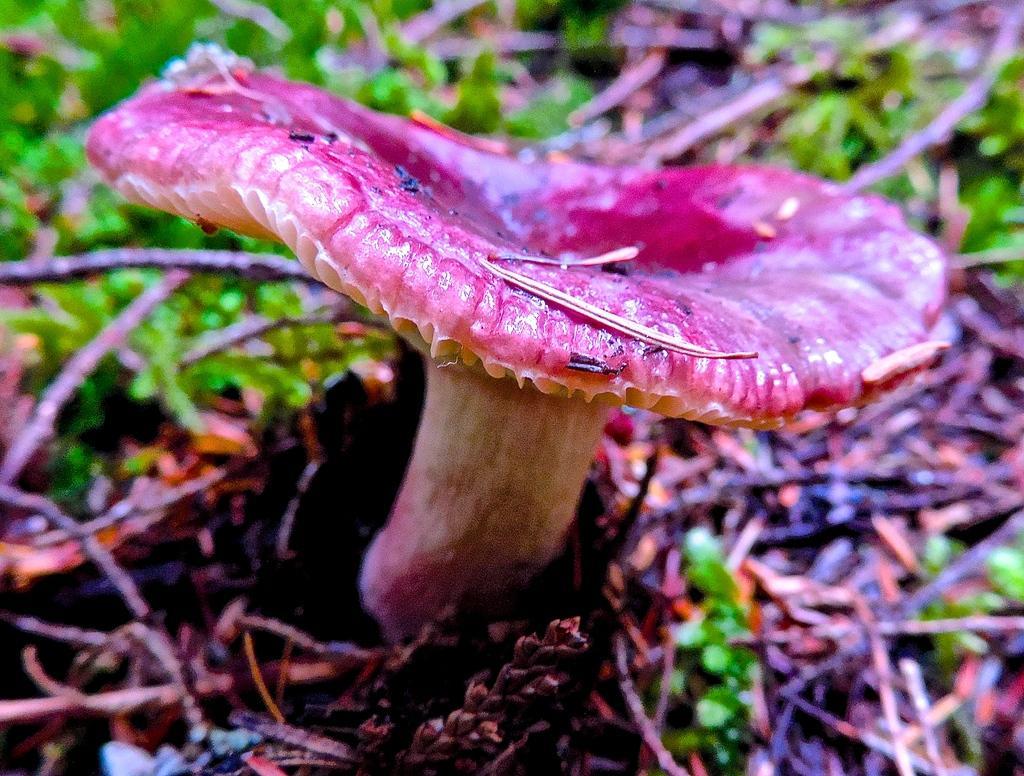Describe this image in one or two sentences. In this picture we can see a mushroom, grass and sticks on the ground. 